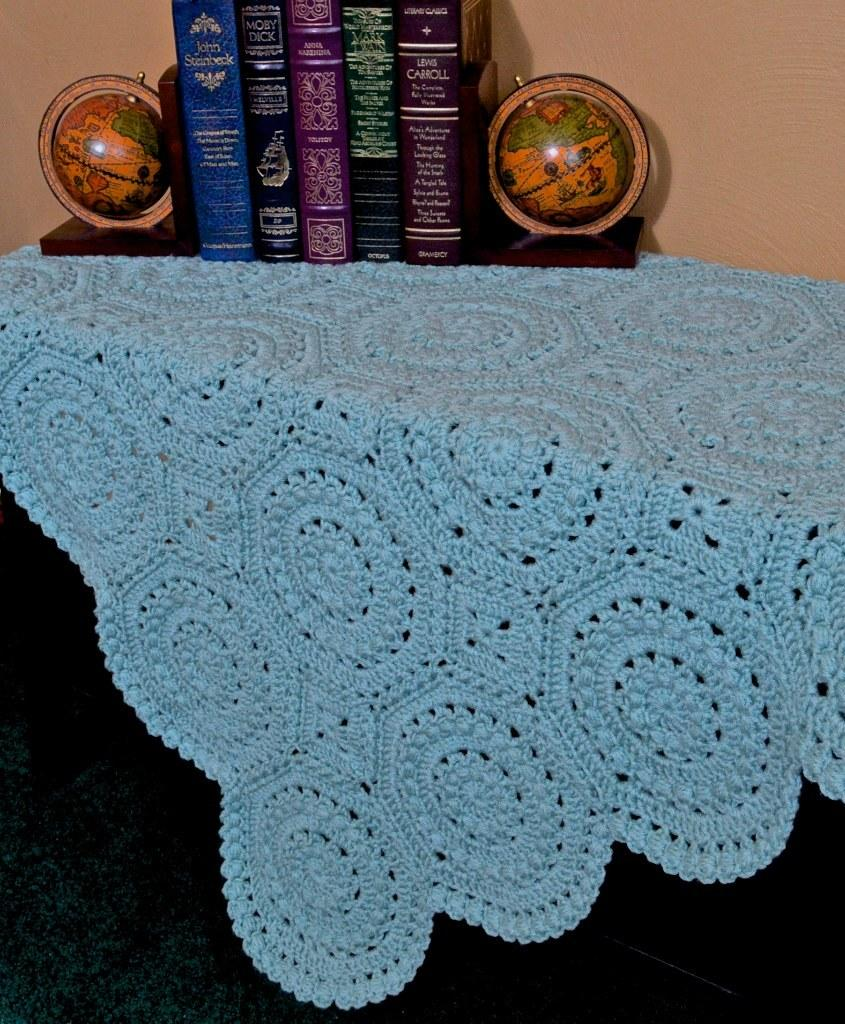<image>
Give a short and clear explanation of the subsequent image. A Lewis Carroll book sits with some other books on a table. 